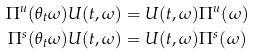Convert formula to latex. <formula><loc_0><loc_0><loc_500><loc_500>\Pi ^ { u } ( \theta _ { t } \omega ) U ( t , \omega ) & = U ( t , \omega ) \Pi ^ { u } ( \omega ) \\ \Pi ^ { s } ( \theta _ { t } \omega ) U ( t , \omega ) & = U ( t , \omega ) \Pi ^ { s } ( \omega )</formula> 